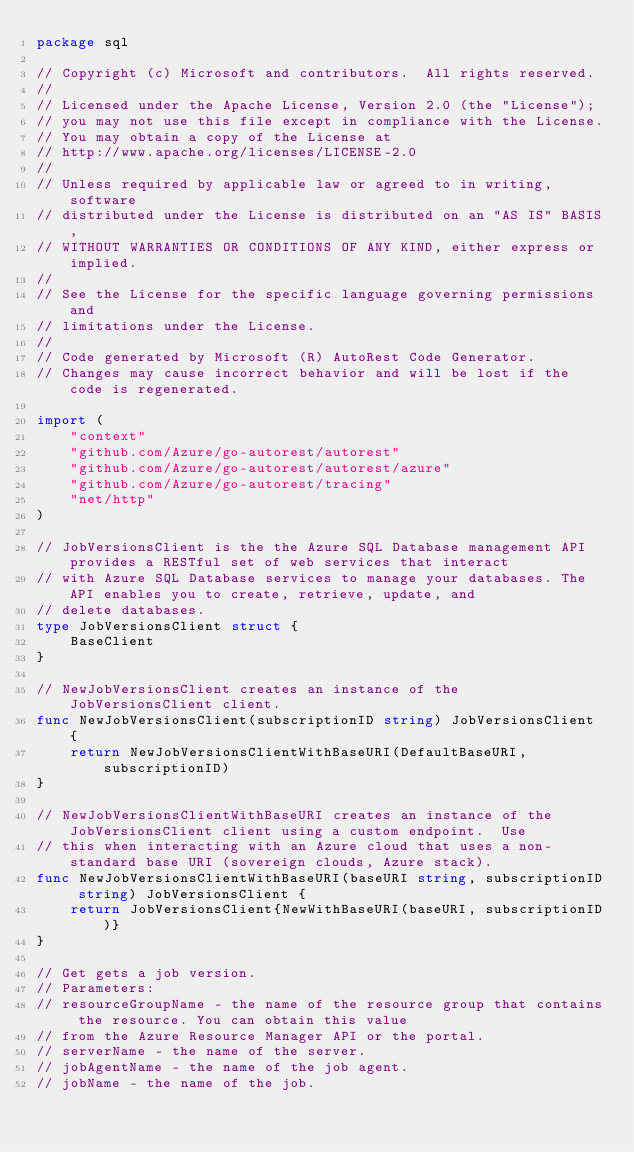Convert code to text. <code><loc_0><loc_0><loc_500><loc_500><_Go_>package sql

// Copyright (c) Microsoft and contributors.  All rights reserved.
//
// Licensed under the Apache License, Version 2.0 (the "License");
// you may not use this file except in compliance with the License.
// You may obtain a copy of the License at
// http://www.apache.org/licenses/LICENSE-2.0
//
// Unless required by applicable law or agreed to in writing, software
// distributed under the License is distributed on an "AS IS" BASIS,
// WITHOUT WARRANTIES OR CONDITIONS OF ANY KIND, either express or implied.
//
// See the License for the specific language governing permissions and
// limitations under the License.
//
// Code generated by Microsoft (R) AutoRest Code Generator.
// Changes may cause incorrect behavior and will be lost if the code is regenerated.

import (
	"context"
	"github.com/Azure/go-autorest/autorest"
	"github.com/Azure/go-autorest/autorest/azure"
	"github.com/Azure/go-autorest/tracing"
	"net/http"
)

// JobVersionsClient is the the Azure SQL Database management API provides a RESTful set of web services that interact
// with Azure SQL Database services to manage your databases. The API enables you to create, retrieve, update, and
// delete databases.
type JobVersionsClient struct {
	BaseClient
}

// NewJobVersionsClient creates an instance of the JobVersionsClient client.
func NewJobVersionsClient(subscriptionID string) JobVersionsClient {
	return NewJobVersionsClientWithBaseURI(DefaultBaseURI, subscriptionID)
}

// NewJobVersionsClientWithBaseURI creates an instance of the JobVersionsClient client using a custom endpoint.  Use
// this when interacting with an Azure cloud that uses a non-standard base URI (sovereign clouds, Azure stack).
func NewJobVersionsClientWithBaseURI(baseURI string, subscriptionID string) JobVersionsClient {
	return JobVersionsClient{NewWithBaseURI(baseURI, subscriptionID)}
}

// Get gets a job version.
// Parameters:
// resourceGroupName - the name of the resource group that contains the resource. You can obtain this value
// from the Azure Resource Manager API or the portal.
// serverName - the name of the server.
// jobAgentName - the name of the job agent.
// jobName - the name of the job.</code> 